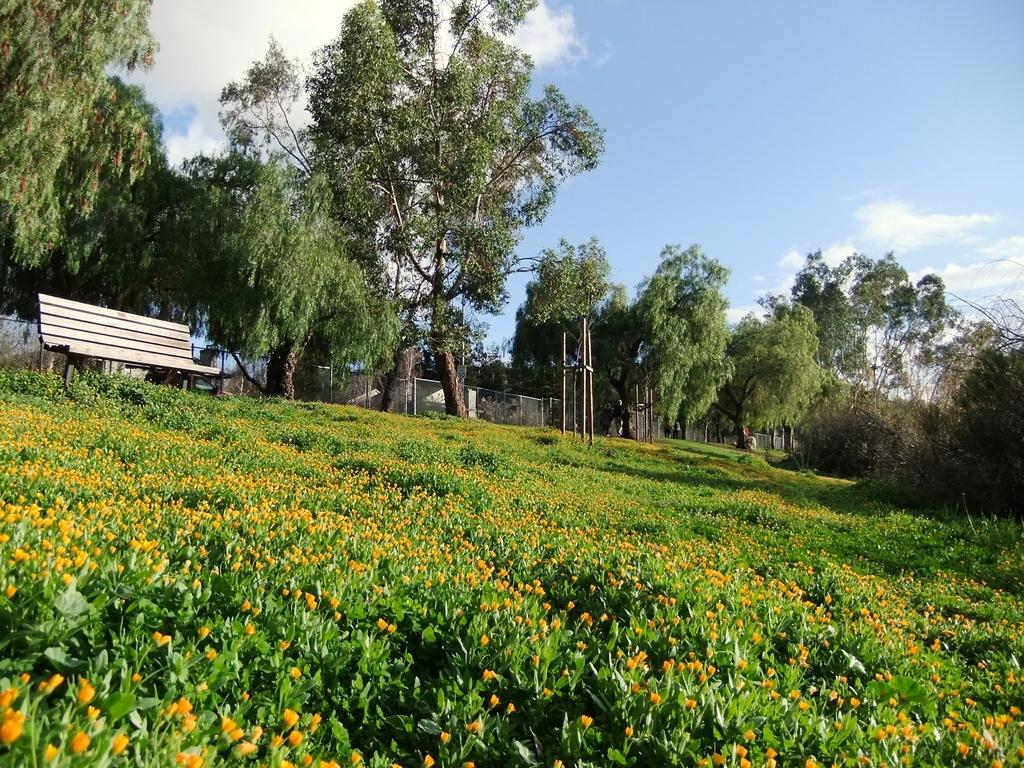What type of vegetation can be seen in the image? There are plants, flowers, and trees in the image. What type of seating is present in the image? There is a bench in the image. What type of barrier is present in the image? There is a fence in the image. What is visible in the sky in the image? The sky is visible in the image, and there are clouds in the sky. What type of request is being made by the scale in the image? There is no scale present in the image, so no such request can be made. 